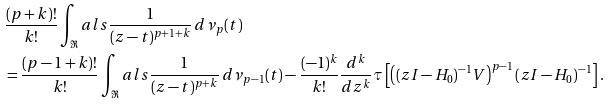Convert formula to latex. <formula><loc_0><loc_0><loc_500><loc_500>& \frac { ( p + k ) ! } { k ! } \int _ { \Re } a l s \frac { 1 } { ( z - t ) ^ { p + 1 + k } } \, d \nu _ { p } ( t ) \\ & = \frac { ( p - 1 + k ) ! } { k ! } \int _ { \Re } a l s \frac { 1 } { ( z - t ) ^ { p + k } } \, d \nu _ { p - 1 } ( t ) - \frac { ( - 1 ) ^ { k } } { k ! } \frac { d ^ { k } } { d z ^ { k } } \tau \left [ \left ( ( z I - H _ { 0 } ) ^ { - 1 } V \right ) ^ { p - 1 } ( z I - H _ { 0 } ) ^ { - 1 } \right ] .</formula> 